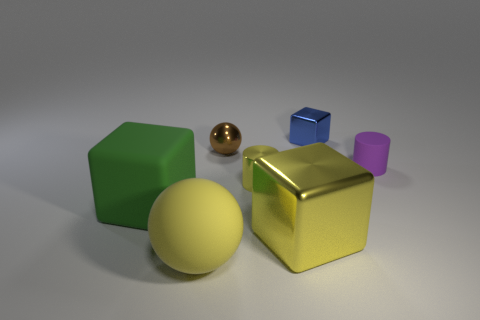Add 1 yellow metal cylinders. How many objects exist? 8 Subtract all yellow blocks. How many blocks are left? 2 Subtract all big cubes. How many cubes are left? 1 Subtract all blocks. How many objects are left? 4 Subtract all small purple rubber cylinders. Subtract all tiny purple shiny blocks. How many objects are left? 6 Add 3 shiny blocks. How many shiny blocks are left? 5 Add 1 rubber objects. How many rubber objects exist? 4 Subtract 0 gray cylinders. How many objects are left? 7 Subtract all blue cylinders. Subtract all brown blocks. How many cylinders are left? 2 Subtract all red cylinders. How many yellow blocks are left? 1 